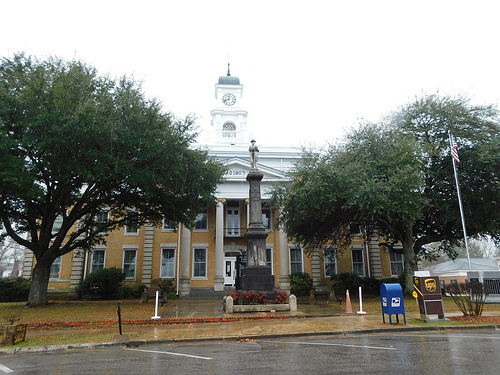<image>
Is there a mailbox under the tree? No. The mailbox is not positioned under the tree. The vertical relationship between these objects is different. Is there a sign board to the right of the glass? Yes. From this viewpoint, the sign board is positioned to the right side relative to the glass. 